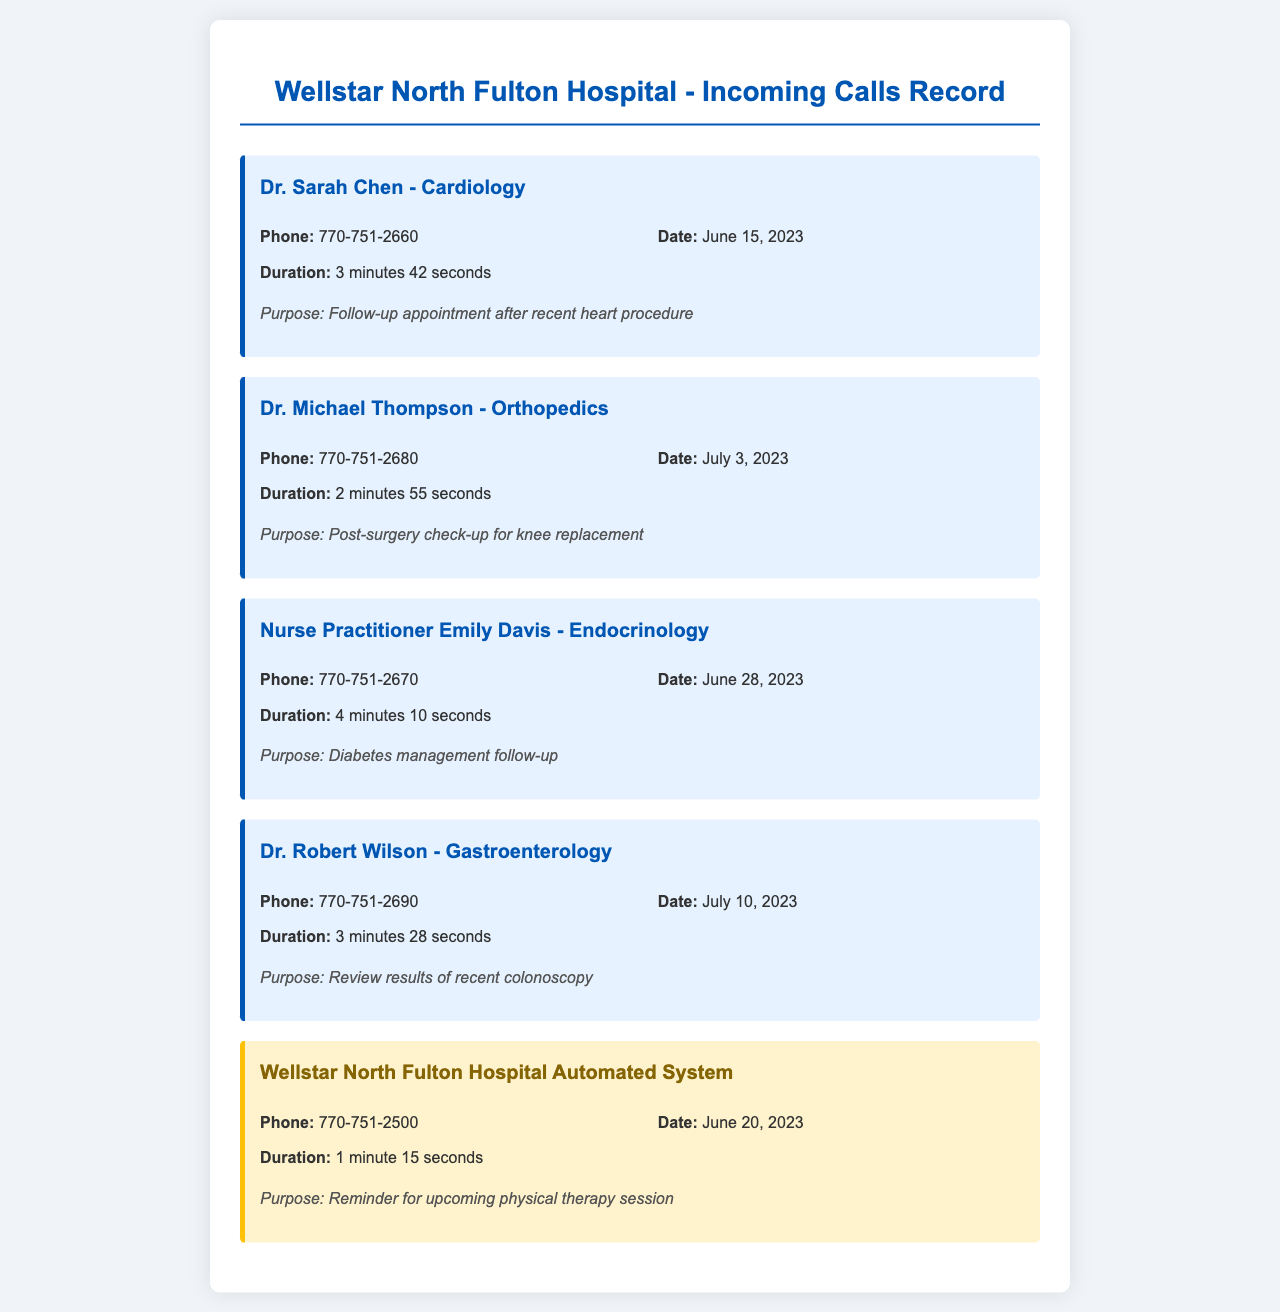What is the name of the cardiologist who called? The document lists the incoming calls, and the cardiologist is named Dr. Sarah Chen.
Answer: Dr. Sarah Chen What was the duration of the call with Dr. Michael Thompson? The call record states that the duration of the call is specifically mentioned for each call, which is 2 minutes 55 seconds for Dr. Thompson.
Answer: 2 minutes 55 seconds What was the purpose of Nurse Practitioner Emily Davis's call? The document specifies the purpose of each call, stating that her call was for diabetes management follow-up.
Answer: Diabetes management follow-up On what date did Dr. Robert Wilson call? The document clearly states the date for each call, which for Dr. Wilson is July 10, 2023.
Answer: July 10, 2023 How many calls were made from Wellstar North Fulton Hospital's automated system? Evaluating the document, it shows that there is one call from the automated system noted in the records.
Answer: One Which medical field does Dr. Michael Thompson specialize in? Each recorded call includes the field of the specialist, and Dr. Thompson specializes in Orthopedics.
Answer: Orthopedics What is the phone number of the automated system? The document lists the phone number of the automated system as part of the call record details.
Answer: 770-751-2500 Who received a call for a follow-up appointment after a heart procedure? The document indicates that Dr. Sarah Chen called for a follow-up appointment after a recent heart procedure.
Answer: Dr. Sarah Chen Which medical specialty is associated with the call on June 28, 2023? The document details the calls and their associated specialties, indicating that the call on this date was related to Endocrinology.
Answer: Endocrinology 